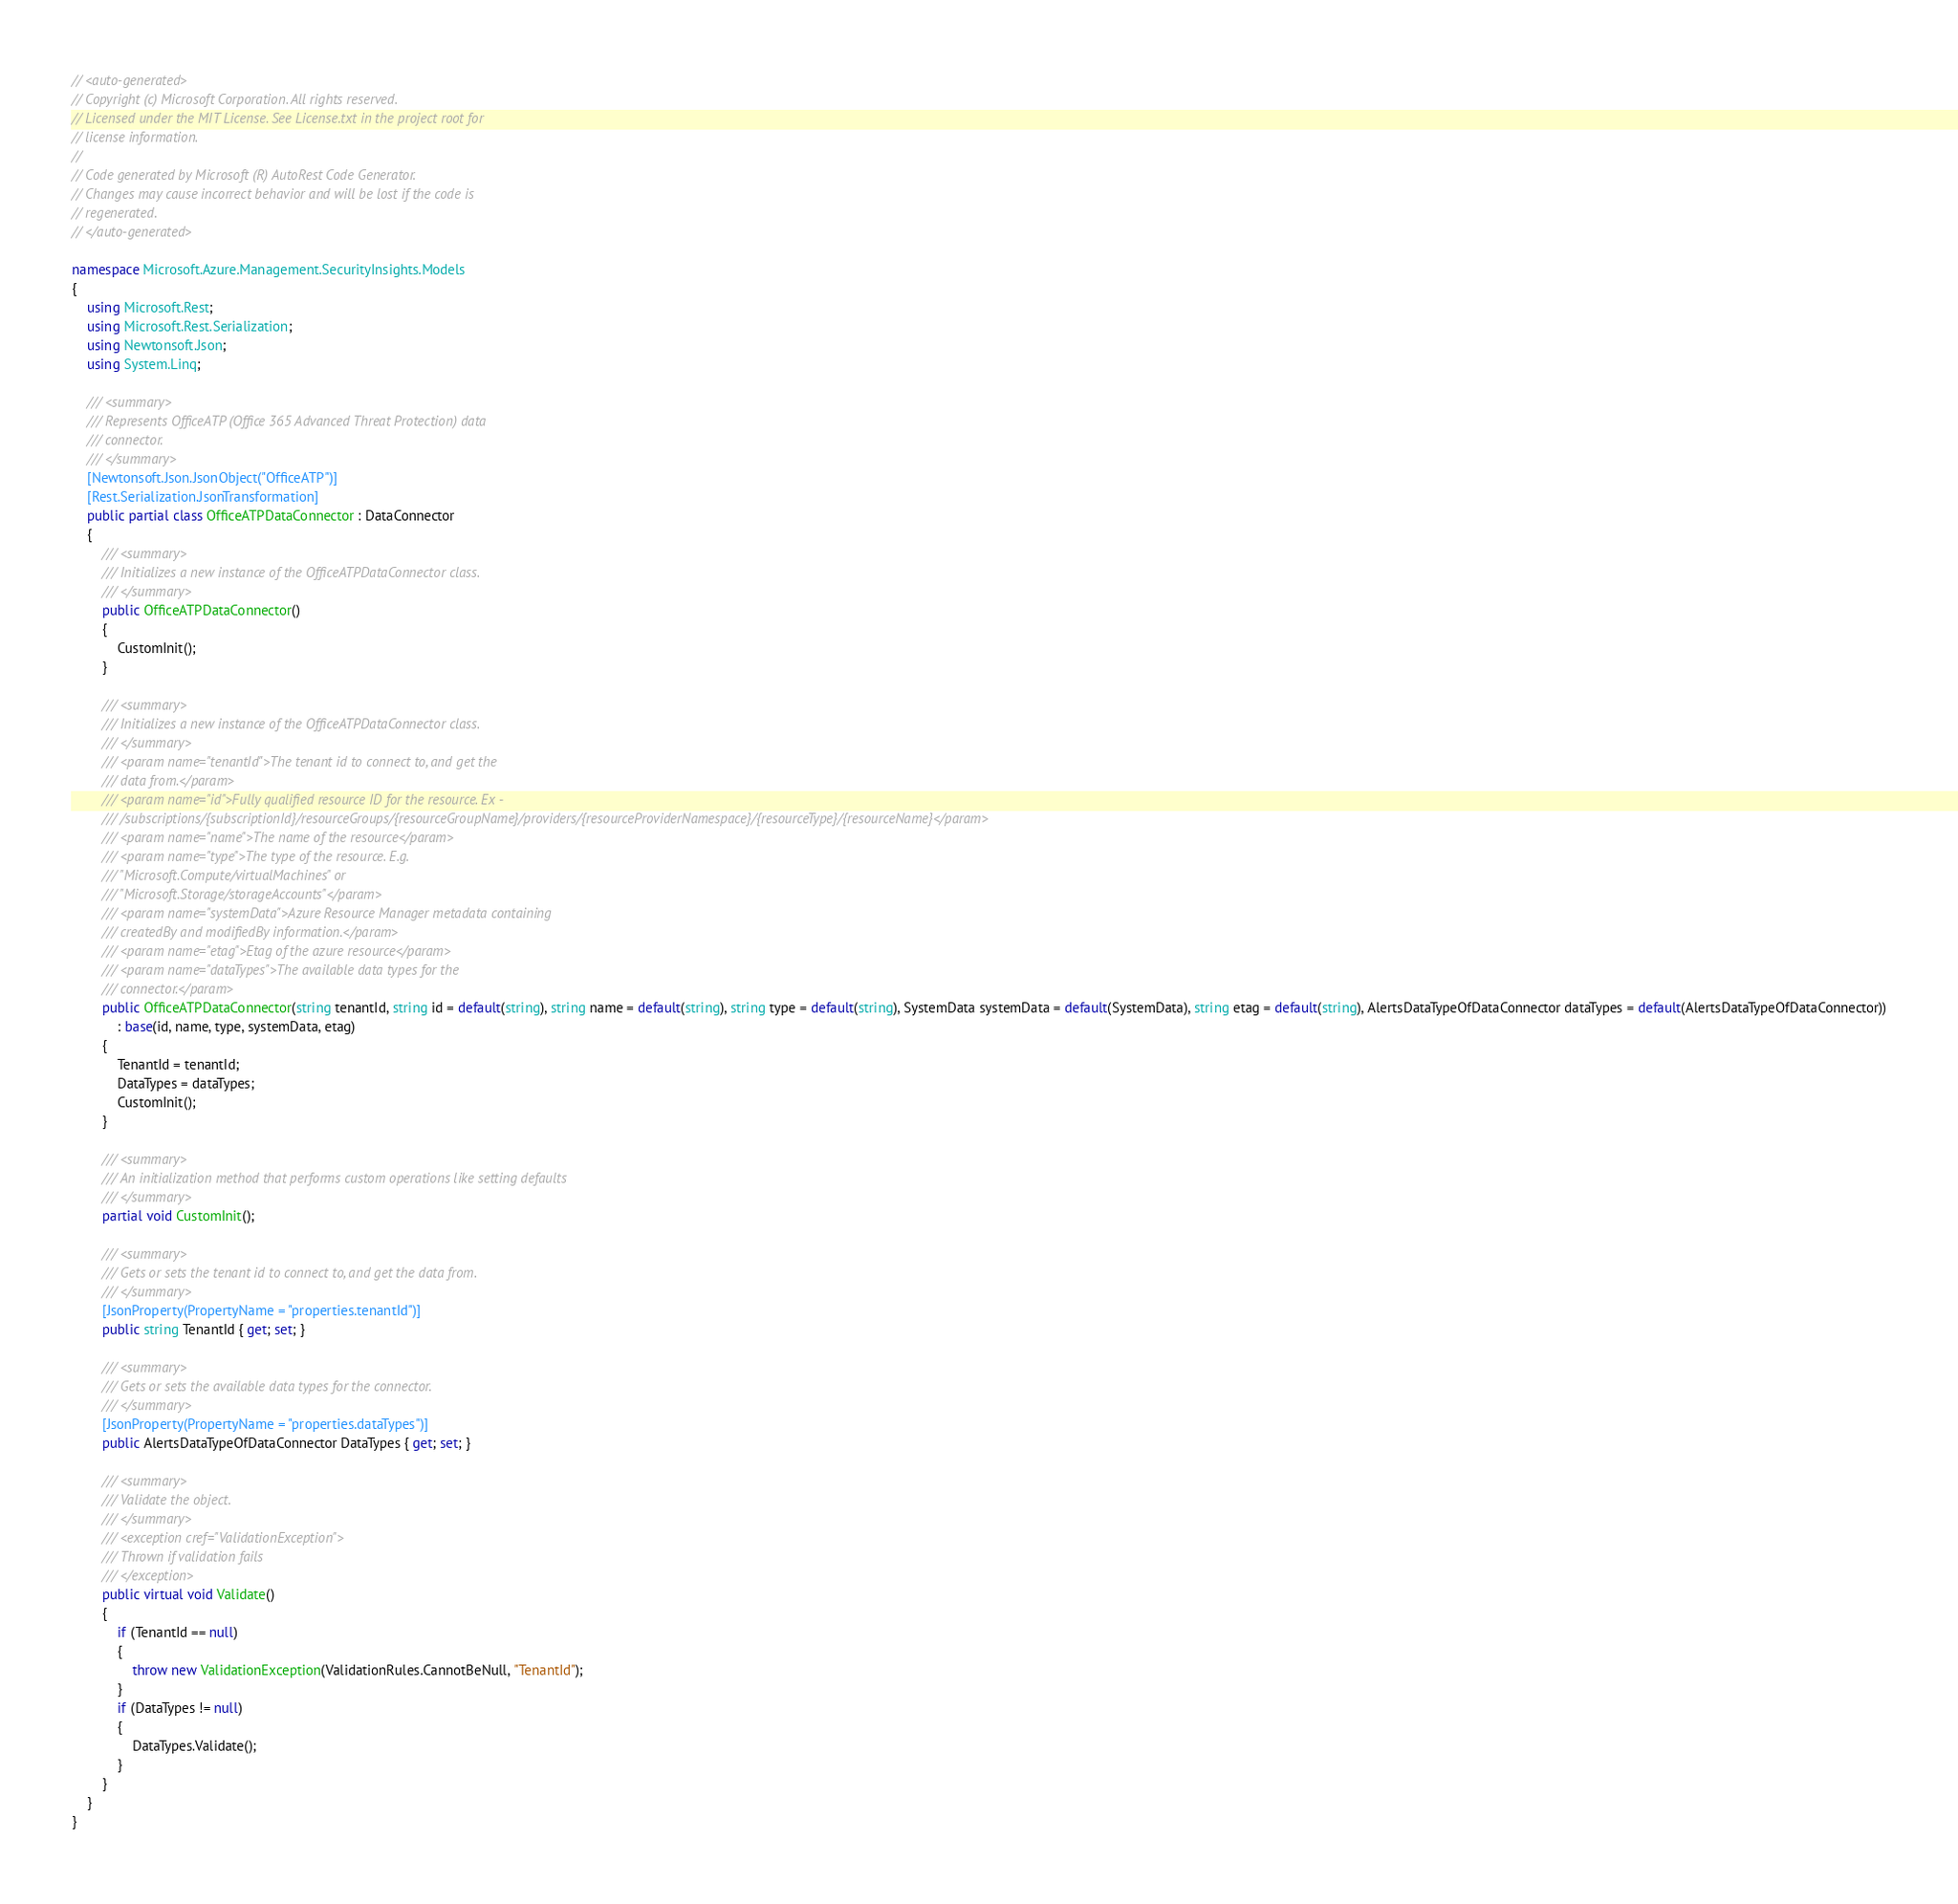<code> <loc_0><loc_0><loc_500><loc_500><_C#_>// <auto-generated>
// Copyright (c) Microsoft Corporation. All rights reserved.
// Licensed under the MIT License. See License.txt in the project root for
// license information.
//
// Code generated by Microsoft (R) AutoRest Code Generator.
// Changes may cause incorrect behavior and will be lost if the code is
// regenerated.
// </auto-generated>

namespace Microsoft.Azure.Management.SecurityInsights.Models
{
    using Microsoft.Rest;
    using Microsoft.Rest.Serialization;
    using Newtonsoft.Json;
    using System.Linq;

    /// <summary>
    /// Represents OfficeATP (Office 365 Advanced Threat Protection) data
    /// connector.
    /// </summary>
    [Newtonsoft.Json.JsonObject("OfficeATP")]
    [Rest.Serialization.JsonTransformation]
    public partial class OfficeATPDataConnector : DataConnector
    {
        /// <summary>
        /// Initializes a new instance of the OfficeATPDataConnector class.
        /// </summary>
        public OfficeATPDataConnector()
        {
            CustomInit();
        }

        /// <summary>
        /// Initializes a new instance of the OfficeATPDataConnector class.
        /// </summary>
        /// <param name="tenantId">The tenant id to connect to, and get the
        /// data from.</param>
        /// <param name="id">Fully qualified resource ID for the resource. Ex -
        /// /subscriptions/{subscriptionId}/resourceGroups/{resourceGroupName}/providers/{resourceProviderNamespace}/{resourceType}/{resourceName}</param>
        /// <param name="name">The name of the resource</param>
        /// <param name="type">The type of the resource. E.g.
        /// "Microsoft.Compute/virtualMachines" or
        /// "Microsoft.Storage/storageAccounts"</param>
        /// <param name="systemData">Azure Resource Manager metadata containing
        /// createdBy and modifiedBy information.</param>
        /// <param name="etag">Etag of the azure resource</param>
        /// <param name="dataTypes">The available data types for the
        /// connector.</param>
        public OfficeATPDataConnector(string tenantId, string id = default(string), string name = default(string), string type = default(string), SystemData systemData = default(SystemData), string etag = default(string), AlertsDataTypeOfDataConnector dataTypes = default(AlertsDataTypeOfDataConnector))
            : base(id, name, type, systemData, etag)
        {
            TenantId = tenantId;
            DataTypes = dataTypes;
            CustomInit();
        }

        /// <summary>
        /// An initialization method that performs custom operations like setting defaults
        /// </summary>
        partial void CustomInit();

        /// <summary>
        /// Gets or sets the tenant id to connect to, and get the data from.
        /// </summary>
        [JsonProperty(PropertyName = "properties.tenantId")]
        public string TenantId { get; set; }

        /// <summary>
        /// Gets or sets the available data types for the connector.
        /// </summary>
        [JsonProperty(PropertyName = "properties.dataTypes")]
        public AlertsDataTypeOfDataConnector DataTypes { get; set; }

        /// <summary>
        /// Validate the object.
        /// </summary>
        /// <exception cref="ValidationException">
        /// Thrown if validation fails
        /// </exception>
        public virtual void Validate()
        {
            if (TenantId == null)
            {
                throw new ValidationException(ValidationRules.CannotBeNull, "TenantId");
            }
            if (DataTypes != null)
            {
                DataTypes.Validate();
            }
        }
    }
}
</code> 